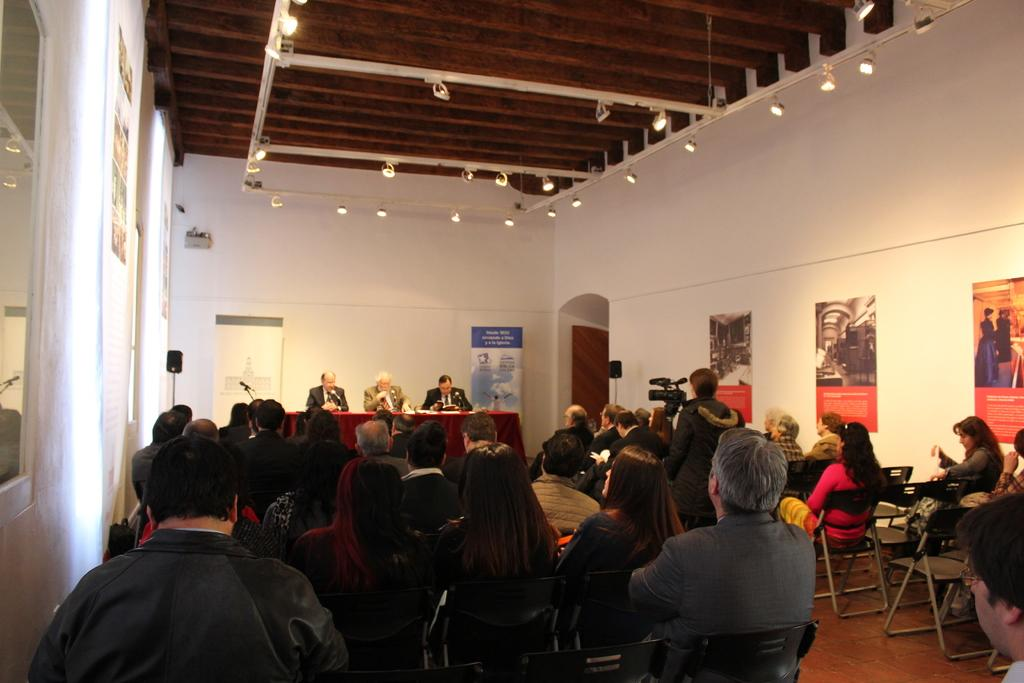What are the people in the image doing? The people in the image are sitting on chairs. What can be seen at the top of the image? There are lights visible at the top of the image. What type of tax is being discussed by the people sitting on chairs in the image? There is no indication in the image that the people are discussing any type of tax. 